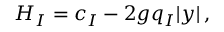<formula> <loc_0><loc_0><loc_500><loc_500>H _ { I } = c _ { I } - 2 g q _ { I } | y | \, ,</formula> 